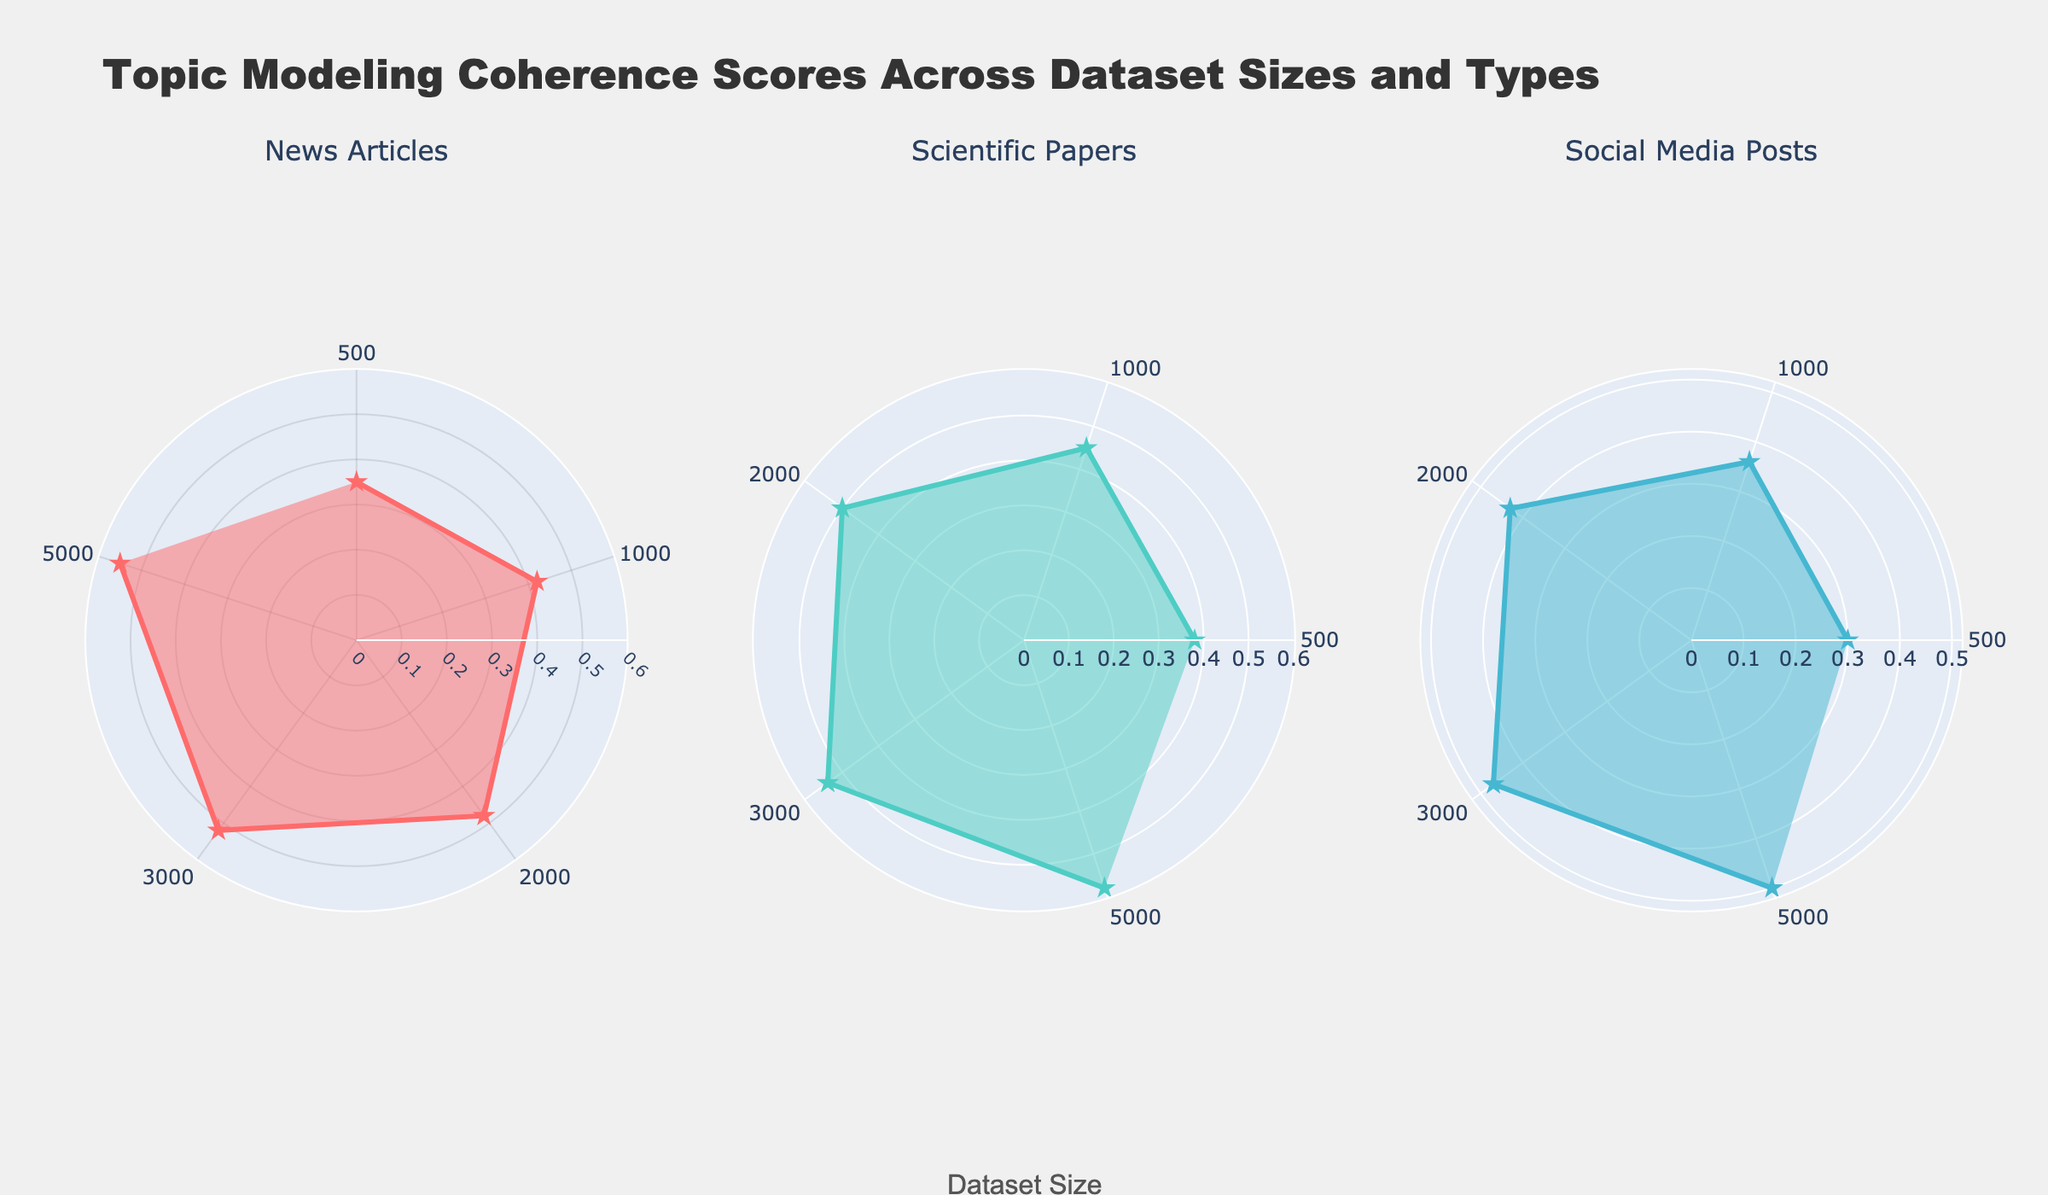What is the range of the coherence scores for News Articles? The plot shows the coherence scores for News Articles ranging from the smallest dataset size of 500 to the largest dataset size of 5000. The coherence scores go from a low of 0.35 to a high of 0.55.
Answer: 0.35 to 0.55 Which dataset type has the highest coherence score at the largest dataset size? To find the dataset type with the highest coherence score at the largest dataset size (5000), you compare the scores at this size across News Articles, Scientific Papers, and Social Media Posts. Scientific Papers have the highest score of 0.58.
Answer: Scientific Papers How does the coherence score of Social Media Posts change as the dataset size increases from 500 to 3000? For Social Media Posts, the coherence score increases from 0.30 at a dataset size of 500 to 0.47 at a dataset size of 3000, showing a steady upward trend.
Answer: Increases from 0.30 to 0.47 What is the average coherence score for News Articles across all dataset sizes shown? Calculate the sum of the coherence scores for News Articles (0.35 + 0.42 + 0.48 + 0.52 + 0.55) and then divide by the number of dataset sizes (5). This results in (0.35 + 0.42 + 0.48 + 0.52 + 0.55) / 5 = 2.32 / 5 = 0.464.
Answer: 0.464 Which has a higher coherence score at a dataset size of 2000, Scientific Papers or Social Media Posts? Looking at the coherence scores for a dataset size of 2000, Scientific Papers have a score of 0.50 and Social Media Posts have a score of 0.43. Therefore, Scientific Papers have a higher score.
Answer: Scientific Papers What is the general trend of coherence scores as dataset size increases across all types? Observing the plots for all types (News Articles, Scientific Papers, and Social Media Posts), as the dataset size increases, the coherence scores generally show an upward trend in all cases, meaning coherence improves with larger dataset sizes.
Answer: Upward trend How many dataset sizes are displayed in the radar charts? The radar charts show coherence scores at five different dataset sizes per type: 500, 1000, 2000, 3000, and 5000.
Answer: Five In which dataset type does the coherence score increase the most between the smallest and largest dataset sizes? Comparing the increase in coherence scores from the smallest to the largest dataset sizes, News Articles increase from 0.35 to 0.55 (0.20 increase), Scientific Papers from 0.38 to 0.58 (0.20 increase), and Social Media Posts from 0.30 to 0.50 (0.20 increase). Every type has the same increase of 0.20.
Answer: All types (0.20) What is the difference between the coherence scores of Scientific Papers and Social Media Posts at a dataset size of 1000? The coherence score for Scientific Papers at a dataset size of 1000 is 0.45, and for Social Media Posts, it is 0.36. The difference is calculated as 0.45 - 0.36 = 0.09.
Answer: 0.09 